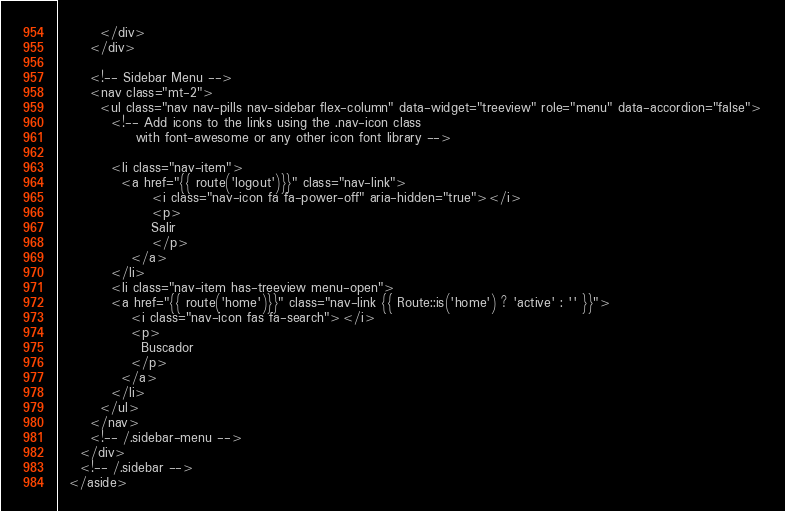Convert code to text. <code><loc_0><loc_0><loc_500><loc_500><_PHP_>        </div>
      </div>

      <!-- Sidebar Menu -->
      <nav class="mt-2">
        <ul class="nav nav-pills nav-sidebar flex-column" data-widget="treeview" role="menu" data-accordion="false">
          <!-- Add icons to the links using the .nav-icon class
               with font-awesome or any other icon font library -->

          <li class="nav-item">
            <a href="{{ route('logout')}}" class="nav-link">
                  <i class="nav-icon fa fa-power-off" aria-hidden="true"></i>
                  <p>
                  Salir
                  </p>
              </a>
          </li>  
          <li class="nav-item has-treeview menu-open">
          <a href="{{ route('home')}}" class="nav-link {{ Route::is('home') ? 'active' : '' }}">
              <i class="nav-icon fas fa-search"></i>
              <p>
                Buscador
              </p>
            </a>
          </li>
        </ul>
      </nav>
      <!-- /.sidebar-menu -->
    </div>
    <!-- /.sidebar -->
  </aside>
</code> 